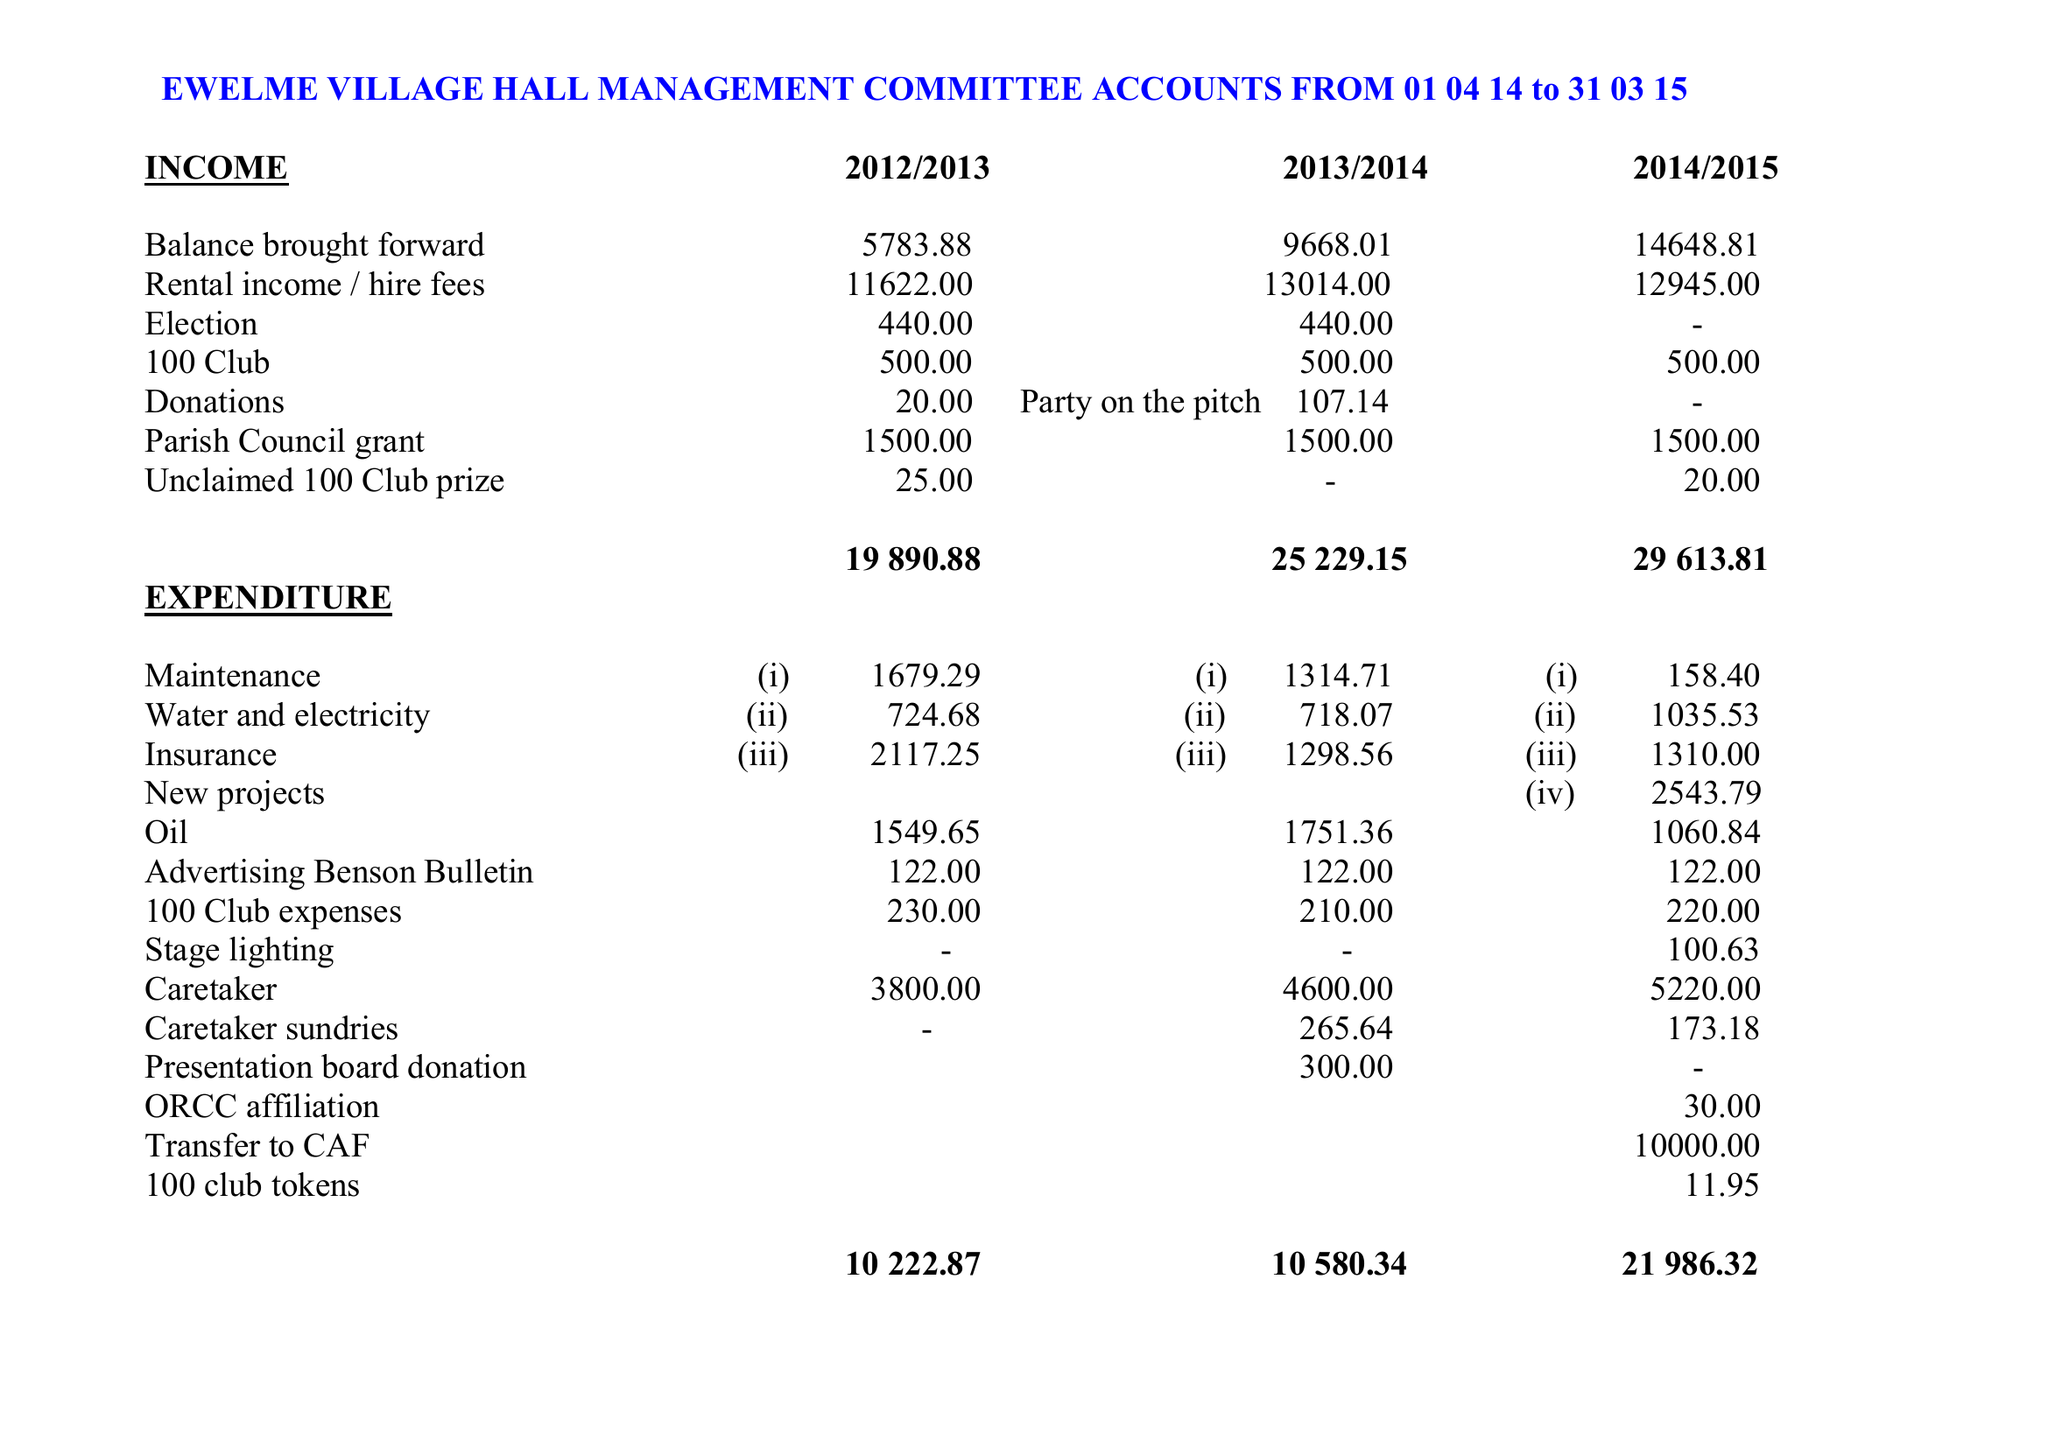What is the value for the report_date?
Answer the question using a single word or phrase. 2015-03-31 